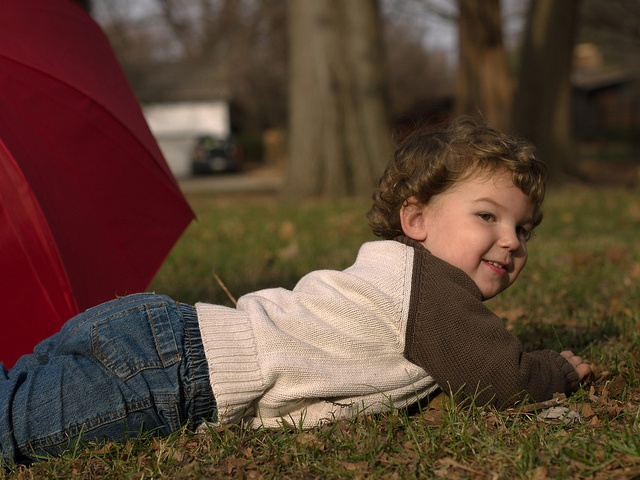Describe the objects in this image and their specific colors. I can see people in maroon, black, and tan tones, umbrella in maroon and darkgreen tones, and car in maroon, black, and gray tones in this image. 